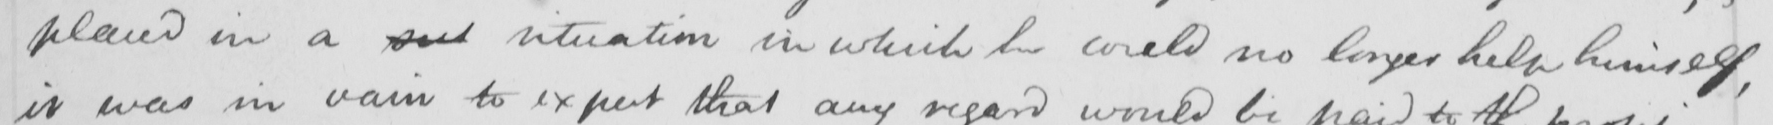Transcribe the text shown in this historical manuscript line. placed in a said situation in which he could no longer help himself , 